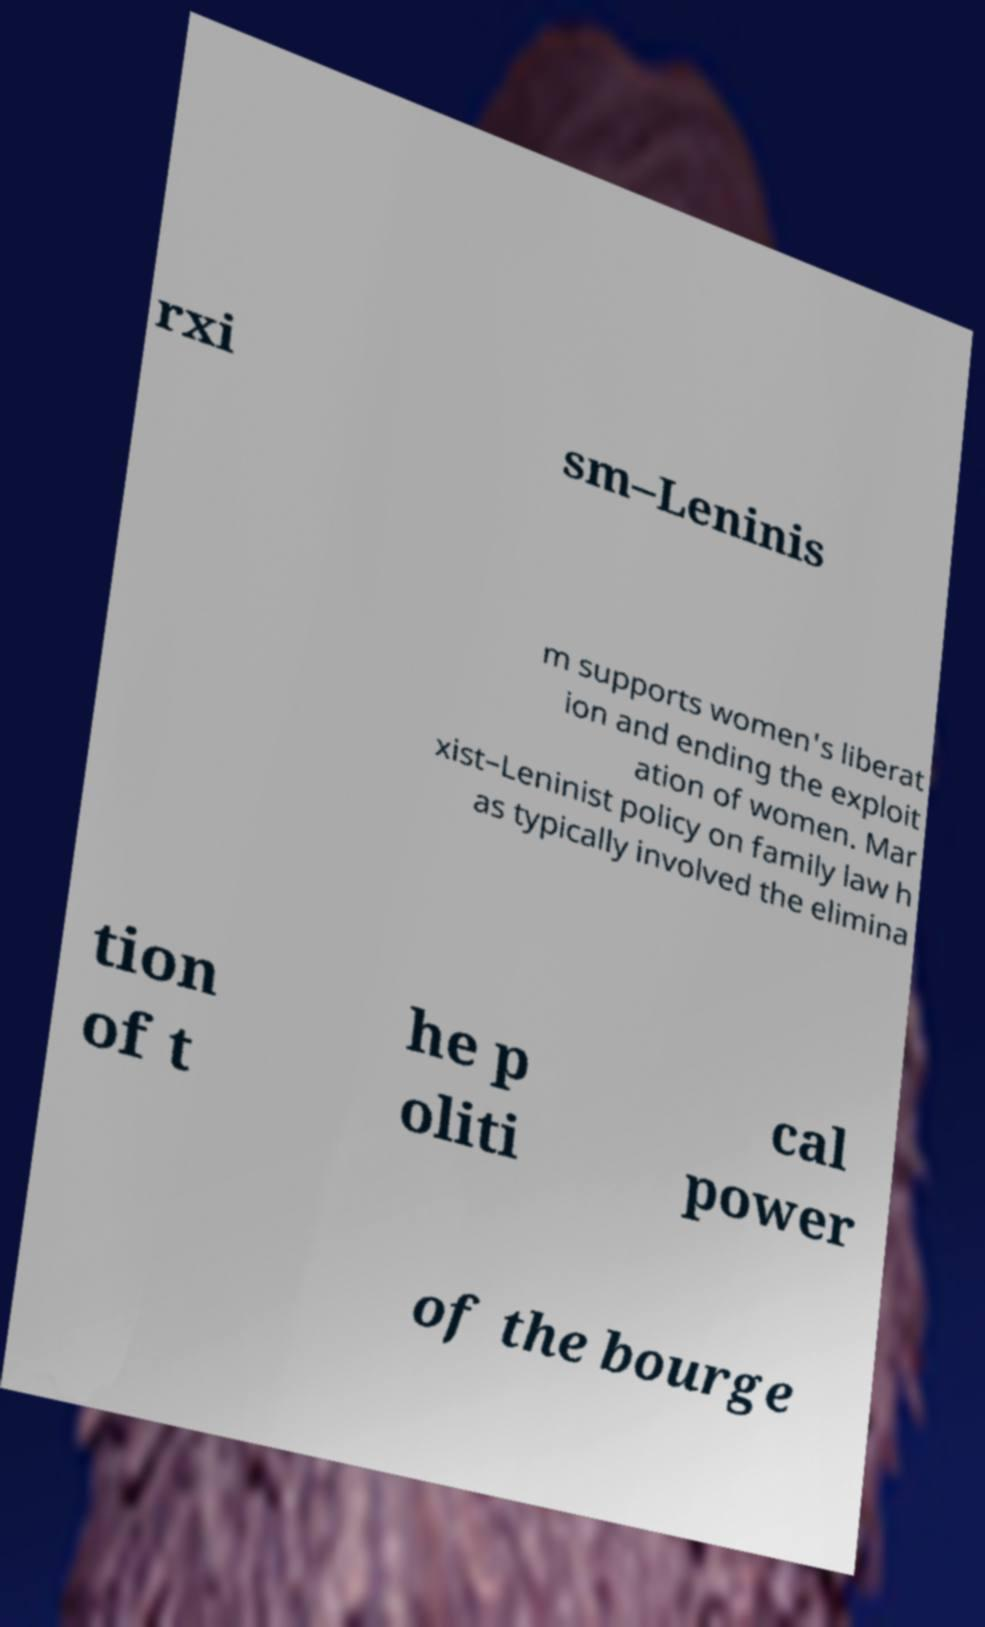Could you assist in decoding the text presented in this image and type it out clearly? rxi sm–Leninis m supports women's liberat ion and ending the exploit ation of women. Mar xist–Leninist policy on family law h as typically involved the elimina tion of t he p oliti cal power of the bourge 